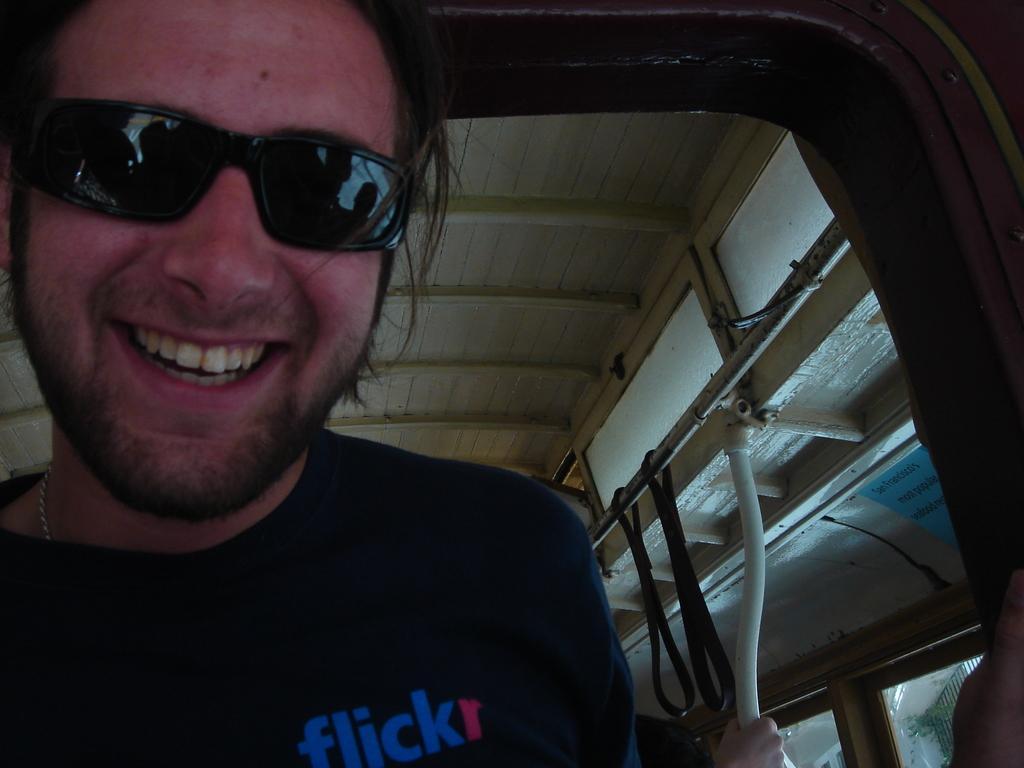How would you summarize this image in a sentence or two? In this image there is a man inside a vehicle, there is a person's hand towards the bottom of the image, there are windows, there is a building, there is a plant, there is a metal rod, there is a wooden roof. 